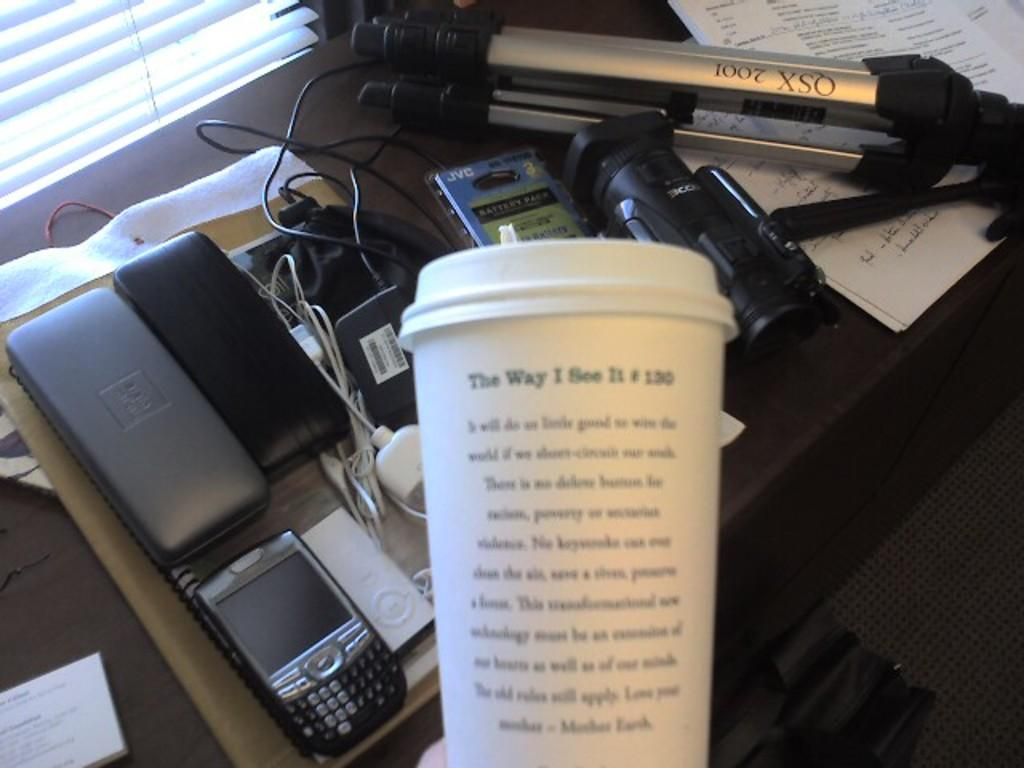Provide a one-sentence caption for the provided image. We see a workstation and the back of the coffee cup that reads The way I see it. 